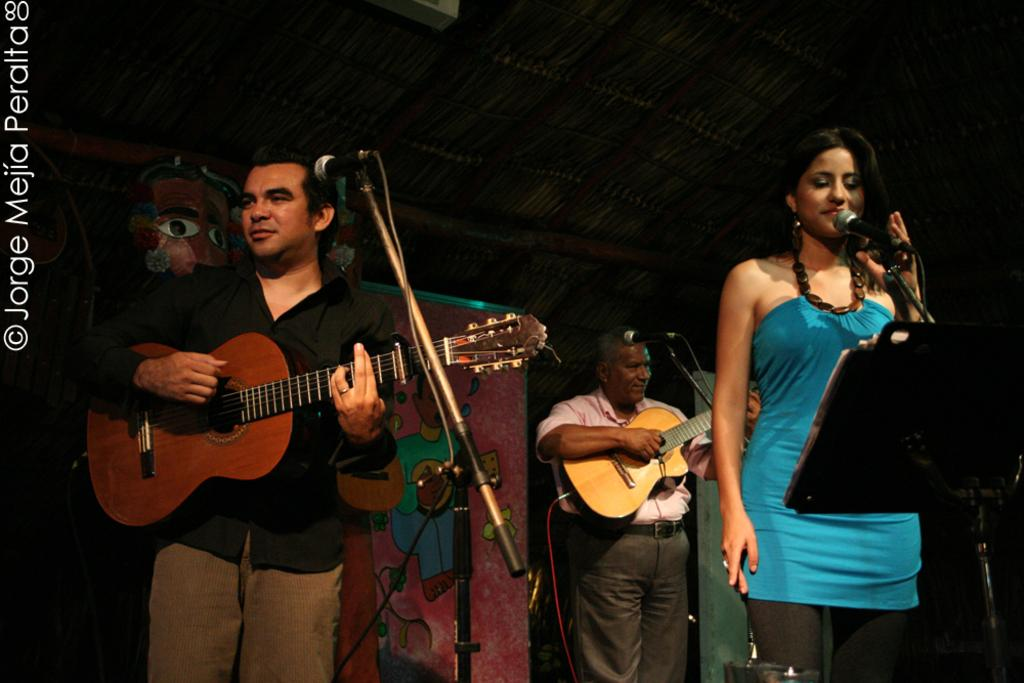What can be seen in the background of the image? There is a poster in the background of the image. What is the woman in the image doing? The woman is standing in front of a mic and singing. What are the two men in the image doing? The two men are standing in front of a mic and playing guitars. What scientific experiment is being conducted in the image? There is no scientific experiment present in the image; it features a woman singing and two men playing guitars. On which side of the stage are the musicians standing? The image does not provide information about the stage or the musicians' positions on it. 